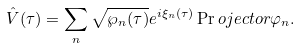<formula> <loc_0><loc_0><loc_500><loc_500>\hat { V } ( \tau ) = \sum _ { n } \sqrt { \wp _ { n } ( \tau ) } e ^ { i \xi _ { n } ( \tau ) } \Pr o j e c t o r { \varphi _ { n } } .</formula> 